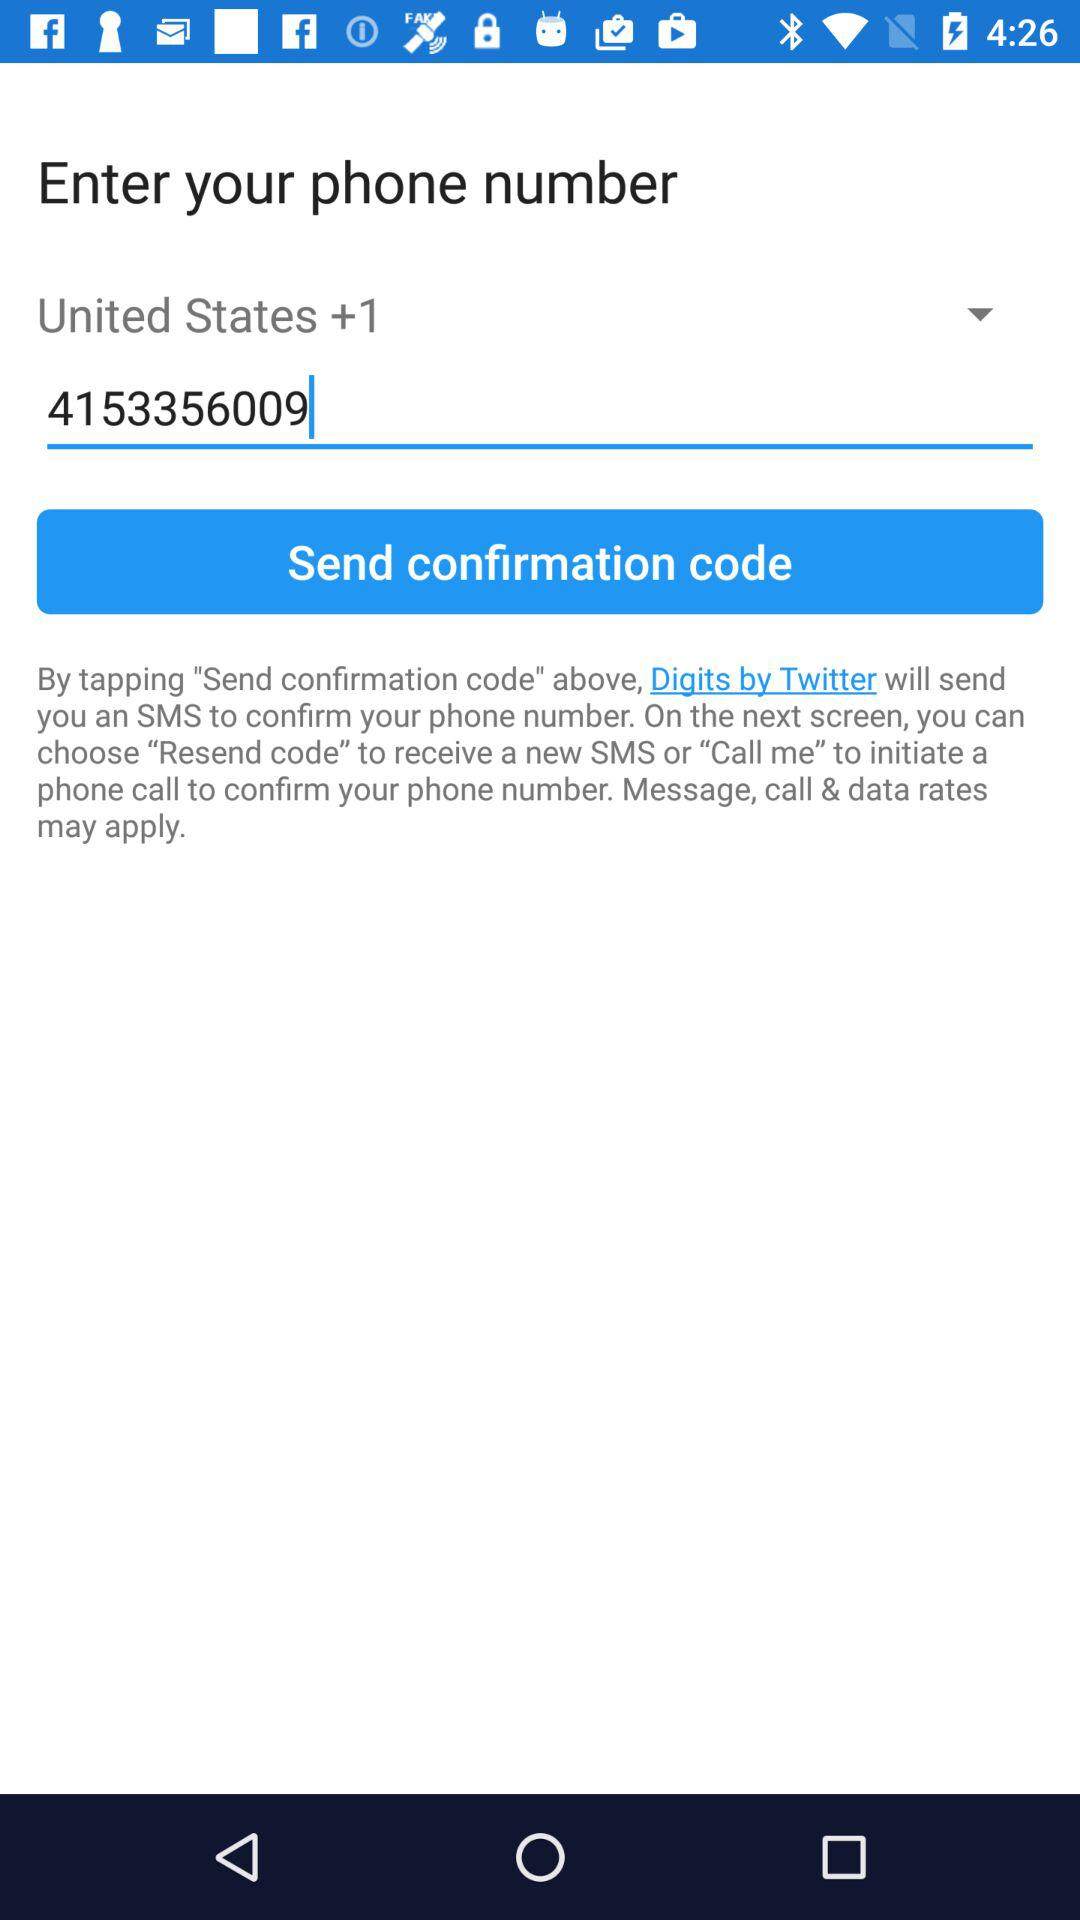What is the phone number? The phone number is 4153356009. 